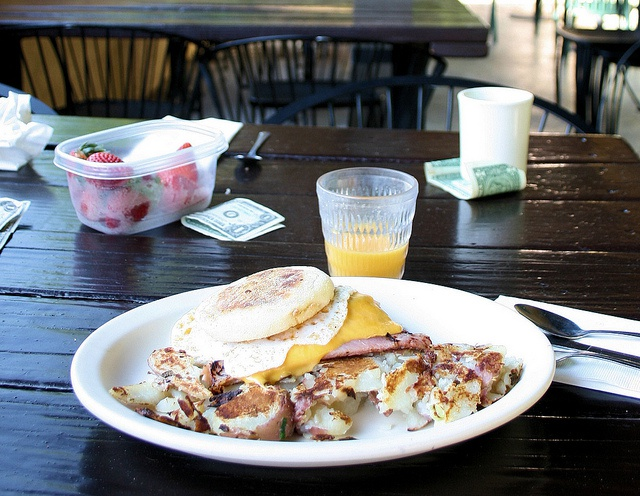Describe the objects in this image and their specific colors. I can see dining table in maroon, black, gray, and darkgray tones, sandwich in maroon, lightgray, brown, darkgray, and beige tones, sandwich in maroon, white, tan, and gold tones, chair in maroon, black, and gray tones, and bowl in maroon, white, darkgray, and lightblue tones in this image. 